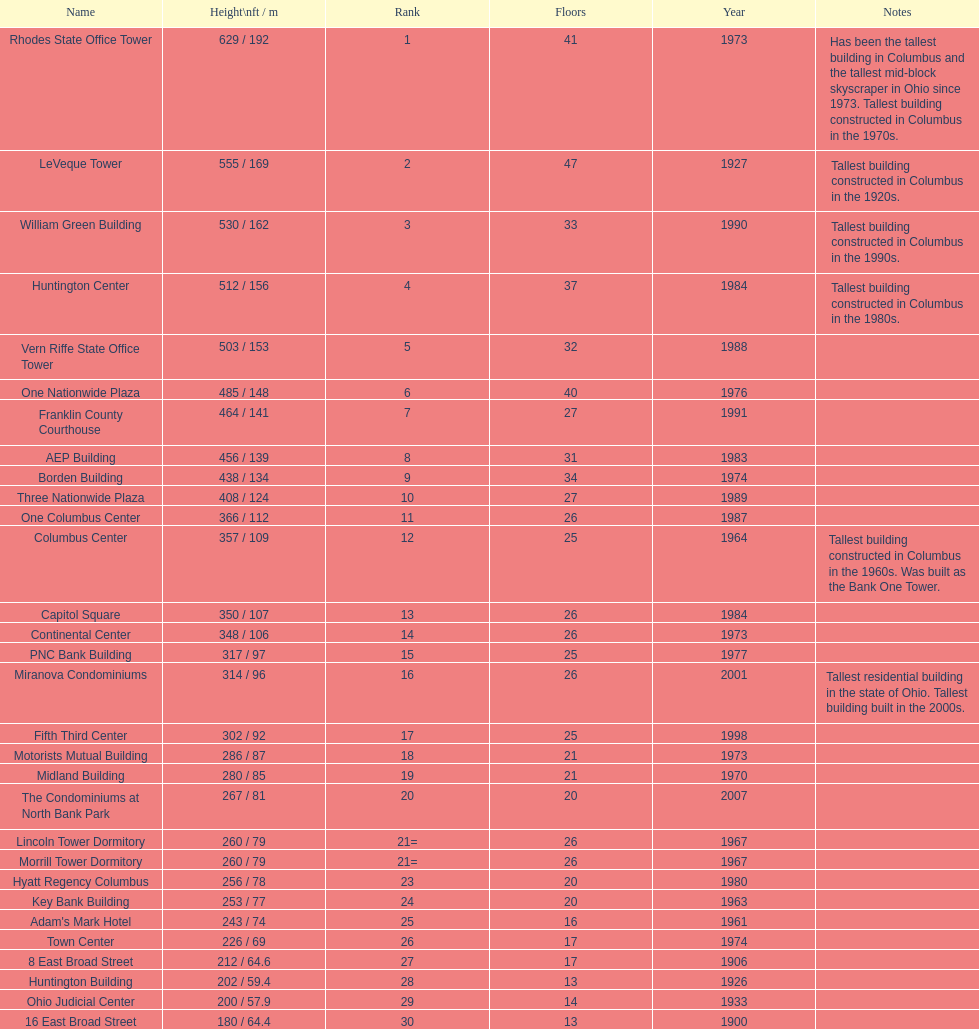Give me the full table as a dictionary. {'header': ['Name', 'Height\\nft / m', 'Rank', 'Floors', 'Year', 'Notes'], 'rows': [['Rhodes State Office Tower', '629 / 192', '1', '41', '1973', 'Has been the tallest building in Columbus and the tallest mid-block skyscraper in Ohio since 1973. Tallest building constructed in Columbus in the 1970s.'], ['LeVeque Tower', '555 / 169', '2', '47', '1927', 'Tallest building constructed in Columbus in the 1920s.'], ['William Green Building', '530 / 162', '3', '33', '1990', 'Tallest building constructed in Columbus in the 1990s.'], ['Huntington Center', '512 / 156', '4', '37', '1984', 'Tallest building constructed in Columbus in the 1980s.'], ['Vern Riffe State Office Tower', '503 / 153', '5', '32', '1988', ''], ['One Nationwide Plaza', '485 / 148', '6', '40', '1976', ''], ['Franklin County Courthouse', '464 / 141', '7', '27', '1991', ''], ['AEP Building', '456 / 139', '8', '31', '1983', ''], ['Borden Building', '438 / 134', '9', '34', '1974', ''], ['Three Nationwide Plaza', '408 / 124', '10', '27', '1989', ''], ['One Columbus Center', '366 / 112', '11', '26', '1987', ''], ['Columbus Center', '357 / 109', '12', '25', '1964', 'Tallest building constructed in Columbus in the 1960s. Was built as the Bank One Tower.'], ['Capitol Square', '350 / 107', '13', '26', '1984', ''], ['Continental Center', '348 / 106', '14', '26', '1973', ''], ['PNC Bank Building', '317 / 97', '15', '25', '1977', ''], ['Miranova Condominiums', '314 / 96', '16', '26', '2001', 'Tallest residential building in the state of Ohio. Tallest building built in the 2000s.'], ['Fifth Third Center', '302 / 92', '17', '25', '1998', ''], ['Motorists Mutual Building', '286 / 87', '18', '21', '1973', ''], ['Midland Building', '280 / 85', '19', '21', '1970', ''], ['The Condominiums at North Bank Park', '267 / 81', '20', '20', '2007', ''], ['Lincoln Tower Dormitory', '260 / 79', '21=', '26', '1967', ''], ['Morrill Tower Dormitory', '260 / 79', '21=', '26', '1967', ''], ['Hyatt Regency Columbus', '256 / 78', '23', '20', '1980', ''], ['Key Bank Building', '253 / 77', '24', '20', '1963', ''], ["Adam's Mark Hotel", '243 / 74', '25', '16', '1961', ''], ['Town Center', '226 / 69', '26', '17', '1974', ''], ['8 East Broad Street', '212 / 64.6', '27', '17', '1906', ''], ['Huntington Building', '202 / 59.4', '28', '13', '1926', ''], ['Ohio Judicial Center', '200 / 57.9', '29', '14', '1933', ''], ['16 East Broad Street', '180 / 64.4', '30', '13', '1900', '']]} How many buildings on this table are taller than 450 feet? 8. 